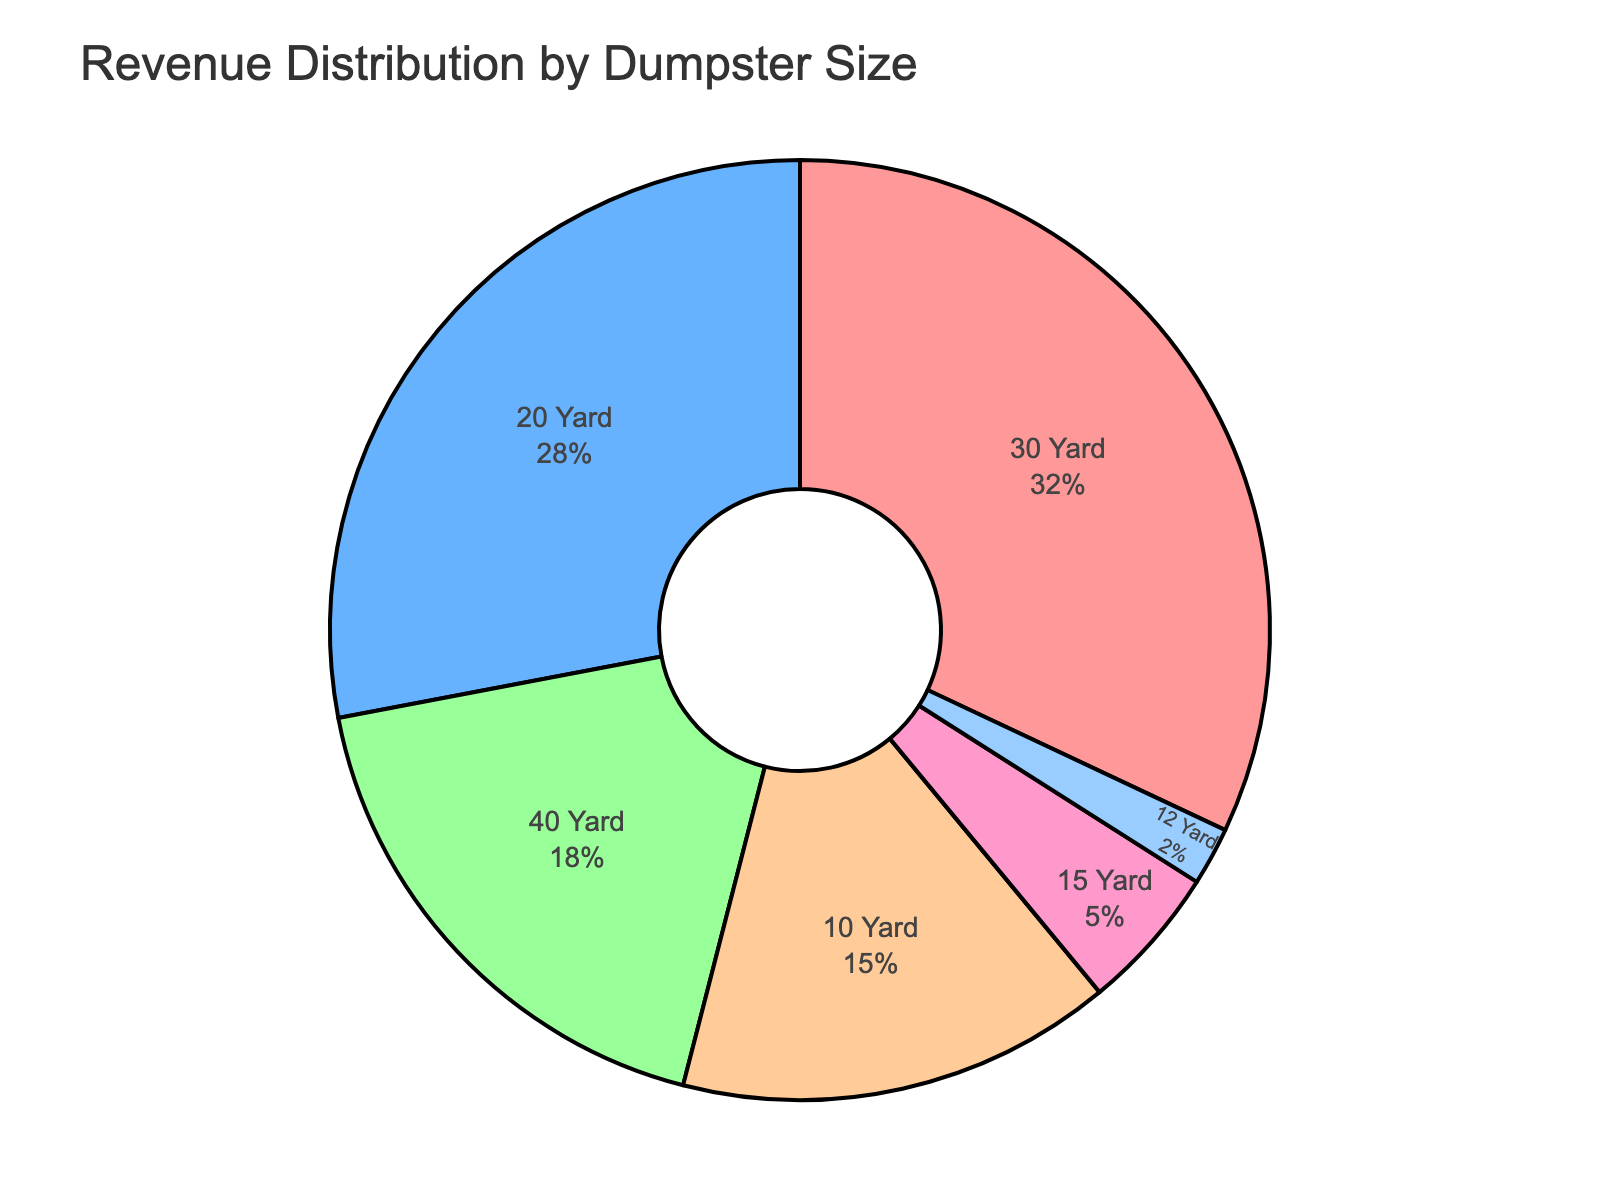What percentage of revenue is generated by the smallest dumpster sizes (10, 12, and 15 Yard)? To find the total percentage of revenue from the 10, 12, and 15 Yard dumpsters, sum up their individual percentages: 10 Yard (15%) + 12 Yard (2%) + 15 Yard (5%).
Answer: 22% Which dumpster size contributes the most to the revenue? The dumpster size with the highest revenue percentage in the pie chart is the 30 Yard dumpster, which contributes 32%.
Answer: 30 Yard How much more revenue does the 20 Yard dumpster generate compared to the 10 Yard dumpster? To determine the extra revenue percentage generated by the 20 Yard dumpster compared to the 10 Yard dumpster, subtract the 10 Yard percentage from the 20 Yard percentage: 28% - 15%.
Answer: 13% What is the combined revenue percentage of the 30 Yard and 40 Yard dumpsters? Add the revenue percentages for the 30 Yard and 40 Yard dumpsters: 32% + 18%.
Answer: 50% What is the percentage difference between the 10 Yard and 15 Yard dumpsters? Subtract the revenue percentage of the 15 Yard dumpster from the 10 Yard dumpster: 15% - 5%.
Answer: 10% What is the median revenue percentage among all dumpster sizes? To find the median, list the percentages in ascending order: 2%, 5%, 15%, 18%, 28%, 32%. The middle values are 15% and 18%, so calculate their average: (15 + 18) / 2.
Answer: 16.5% Which dumpster size contributes the least to the revenue? The dumpster size with the lowest revenue percentage is the 12 Yard dumpster at 2%.
Answer: 12 Yard How does the revenue contribution of the 40 Yard dumpster compare to the 20 Yard dumpster? The 40 Yard dumpster has a revenue percentage of 18%, whereas the 20 Yard dumpster has 28%. Therefore, the 20 Yard dumpster generates 10% more revenue than the 40 Yard dumpster.
Answer: 20 Yard What is the total revenue percentage for all dumpster sizes above 15%? Sum the percentages of all dumpster sizes above 15%: 20 Yard (28%) + 30 Yard (32%) + 40 Yard (18%).
Answer: 78% By how much does the 30 Yard dumpster's revenue exceed the sum of revenue from both the 12 Yard and 15 Yard dumpsters? First, calculate the sum of the revenue percentages for 12 Yard and 15 Yard dumpsters: 2% + 5% = 7%. Then, subtract this sum from the 30 Yard dumpster's revenue percentage: 32% - 7%.
Answer: 25% 